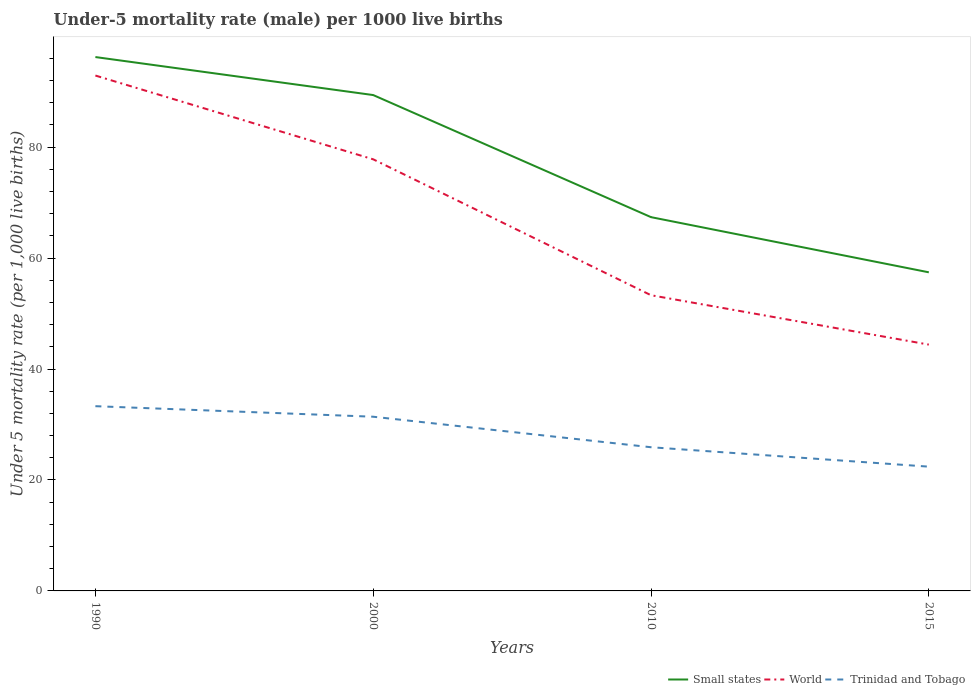Is the number of lines equal to the number of legend labels?
Keep it short and to the point. Yes. Across all years, what is the maximum under-five mortality rate in Small states?
Make the answer very short. 57.43. In which year was the under-five mortality rate in World maximum?
Your answer should be compact. 2015. What is the difference between the highest and the second highest under-five mortality rate in World?
Make the answer very short. 48.5. Is the under-five mortality rate in Small states strictly greater than the under-five mortality rate in Trinidad and Tobago over the years?
Your response must be concise. No. Does the graph contain any zero values?
Your response must be concise. No. How many legend labels are there?
Provide a succinct answer. 3. What is the title of the graph?
Provide a short and direct response. Under-5 mortality rate (male) per 1000 live births. What is the label or title of the Y-axis?
Provide a succinct answer. Under 5 mortality rate (per 1,0 live births). What is the Under 5 mortality rate (per 1,000 live births) in Small states in 1990?
Give a very brief answer. 96.23. What is the Under 5 mortality rate (per 1,000 live births) of World in 1990?
Give a very brief answer. 92.9. What is the Under 5 mortality rate (per 1,000 live births) in Trinidad and Tobago in 1990?
Your answer should be very brief. 33.3. What is the Under 5 mortality rate (per 1,000 live births) in Small states in 2000?
Keep it short and to the point. 89.38. What is the Under 5 mortality rate (per 1,000 live births) in World in 2000?
Provide a short and direct response. 77.8. What is the Under 5 mortality rate (per 1,000 live births) of Trinidad and Tobago in 2000?
Your answer should be compact. 31.4. What is the Under 5 mortality rate (per 1,000 live births) in Small states in 2010?
Your answer should be compact. 67.37. What is the Under 5 mortality rate (per 1,000 live births) in World in 2010?
Make the answer very short. 53.3. What is the Under 5 mortality rate (per 1,000 live births) in Trinidad and Tobago in 2010?
Offer a very short reply. 25.9. What is the Under 5 mortality rate (per 1,000 live births) of Small states in 2015?
Ensure brevity in your answer.  57.43. What is the Under 5 mortality rate (per 1,000 live births) in World in 2015?
Offer a very short reply. 44.4. What is the Under 5 mortality rate (per 1,000 live births) in Trinidad and Tobago in 2015?
Make the answer very short. 22.4. Across all years, what is the maximum Under 5 mortality rate (per 1,000 live births) of Small states?
Provide a short and direct response. 96.23. Across all years, what is the maximum Under 5 mortality rate (per 1,000 live births) in World?
Provide a short and direct response. 92.9. Across all years, what is the maximum Under 5 mortality rate (per 1,000 live births) of Trinidad and Tobago?
Provide a short and direct response. 33.3. Across all years, what is the minimum Under 5 mortality rate (per 1,000 live births) of Small states?
Your answer should be very brief. 57.43. Across all years, what is the minimum Under 5 mortality rate (per 1,000 live births) in World?
Make the answer very short. 44.4. Across all years, what is the minimum Under 5 mortality rate (per 1,000 live births) in Trinidad and Tobago?
Your response must be concise. 22.4. What is the total Under 5 mortality rate (per 1,000 live births) of Small states in the graph?
Keep it short and to the point. 310.42. What is the total Under 5 mortality rate (per 1,000 live births) in World in the graph?
Ensure brevity in your answer.  268.4. What is the total Under 5 mortality rate (per 1,000 live births) in Trinidad and Tobago in the graph?
Keep it short and to the point. 113. What is the difference between the Under 5 mortality rate (per 1,000 live births) in Small states in 1990 and that in 2000?
Your response must be concise. 6.85. What is the difference between the Under 5 mortality rate (per 1,000 live births) of World in 1990 and that in 2000?
Offer a terse response. 15.1. What is the difference between the Under 5 mortality rate (per 1,000 live births) in Trinidad and Tobago in 1990 and that in 2000?
Ensure brevity in your answer.  1.9. What is the difference between the Under 5 mortality rate (per 1,000 live births) of Small states in 1990 and that in 2010?
Keep it short and to the point. 28.86. What is the difference between the Under 5 mortality rate (per 1,000 live births) in World in 1990 and that in 2010?
Give a very brief answer. 39.6. What is the difference between the Under 5 mortality rate (per 1,000 live births) of Trinidad and Tobago in 1990 and that in 2010?
Give a very brief answer. 7.4. What is the difference between the Under 5 mortality rate (per 1,000 live births) in Small states in 1990 and that in 2015?
Give a very brief answer. 38.8. What is the difference between the Under 5 mortality rate (per 1,000 live births) in World in 1990 and that in 2015?
Give a very brief answer. 48.5. What is the difference between the Under 5 mortality rate (per 1,000 live births) in Trinidad and Tobago in 1990 and that in 2015?
Your answer should be compact. 10.9. What is the difference between the Under 5 mortality rate (per 1,000 live births) of Small states in 2000 and that in 2010?
Keep it short and to the point. 22.01. What is the difference between the Under 5 mortality rate (per 1,000 live births) in World in 2000 and that in 2010?
Provide a succinct answer. 24.5. What is the difference between the Under 5 mortality rate (per 1,000 live births) in Small states in 2000 and that in 2015?
Ensure brevity in your answer.  31.95. What is the difference between the Under 5 mortality rate (per 1,000 live births) of World in 2000 and that in 2015?
Your answer should be compact. 33.4. What is the difference between the Under 5 mortality rate (per 1,000 live births) in Trinidad and Tobago in 2000 and that in 2015?
Keep it short and to the point. 9. What is the difference between the Under 5 mortality rate (per 1,000 live births) of Small states in 2010 and that in 2015?
Offer a terse response. 9.94. What is the difference between the Under 5 mortality rate (per 1,000 live births) of Small states in 1990 and the Under 5 mortality rate (per 1,000 live births) of World in 2000?
Offer a terse response. 18.43. What is the difference between the Under 5 mortality rate (per 1,000 live births) of Small states in 1990 and the Under 5 mortality rate (per 1,000 live births) of Trinidad and Tobago in 2000?
Offer a very short reply. 64.83. What is the difference between the Under 5 mortality rate (per 1,000 live births) in World in 1990 and the Under 5 mortality rate (per 1,000 live births) in Trinidad and Tobago in 2000?
Make the answer very short. 61.5. What is the difference between the Under 5 mortality rate (per 1,000 live births) of Small states in 1990 and the Under 5 mortality rate (per 1,000 live births) of World in 2010?
Keep it short and to the point. 42.93. What is the difference between the Under 5 mortality rate (per 1,000 live births) of Small states in 1990 and the Under 5 mortality rate (per 1,000 live births) of Trinidad and Tobago in 2010?
Provide a short and direct response. 70.33. What is the difference between the Under 5 mortality rate (per 1,000 live births) of Small states in 1990 and the Under 5 mortality rate (per 1,000 live births) of World in 2015?
Offer a very short reply. 51.83. What is the difference between the Under 5 mortality rate (per 1,000 live births) of Small states in 1990 and the Under 5 mortality rate (per 1,000 live births) of Trinidad and Tobago in 2015?
Keep it short and to the point. 73.83. What is the difference between the Under 5 mortality rate (per 1,000 live births) in World in 1990 and the Under 5 mortality rate (per 1,000 live births) in Trinidad and Tobago in 2015?
Your response must be concise. 70.5. What is the difference between the Under 5 mortality rate (per 1,000 live births) of Small states in 2000 and the Under 5 mortality rate (per 1,000 live births) of World in 2010?
Offer a very short reply. 36.08. What is the difference between the Under 5 mortality rate (per 1,000 live births) in Small states in 2000 and the Under 5 mortality rate (per 1,000 live births) in Trinidad and Tobago in 2010?
Provide a succinct answer. 63.48. What is the difference between the Under 5 mortality rate (per 1,000 live births) in World in 2000 and the Under 5 mortality rate (per 1,000 live births) in Trinidad and Tobago in 2010?
Provide a short and direct response. 51.9. What is the difference between the Under 5 mortality rate (per 1,000 live births) in Small states in 2000 and the Under 5 mortality rate (per 1,000 live births) in World in 2015?
Offer a very short reply. 44.98. What is the difference between the Under 5 mortality rate (per 1,000 live births) in Small states in 2000 and the Under 5 mortality rate (per 1,000 live births) in Trinidad and Tobago in 2015?
Keep it short and to the point. 66.98. What is the difference between the Under 5 mortality rate (per 1,000 live births) in World in 2000 and the Under 5 mortality rate (per 1,000 live births) in Trinidad and Tobago in 2015?
Provide a succinct answer. 55.4. What is the difference between the Under 5 mortality rate (per 1,000 live births) in Small states in 2010 and the Under 5 mortality rate (per 1,000 live births) in World in 2015?
Give a very brief answer. 22.97. What is the difference between the Under 5 mortality rate (per 1,000 live births) in Small states in 2010 and the Under 5 mortality rate (per 1,000 live births) in Trinidad and Tobago in 2015?
Ensure brevity in your answer.  44.97. What is the difference between the Under 5 mortality rate (per 1,000 live births) of World in 2010 and the Under 5 mortality rate (per 1,000 live births) of Trinidad and Tobago in 2015?
Offer a very short reply. 30.9. What is the average Under 5 mortality rate (per 1,000 live births) of Small states per year?
Your answer should be very brief. 77.6. What is the average Under 5 mortality rate (per 1,000 live births) of World per year?
Give a very brief answer. 67.1. What is the average Under 5 mortality rate (per 1,000 live births) in Trinidad and Tobago per year?
Keep it short and to the point. 28.25. In the year 1990, what is the difference between the Under 5 mortality rate (per 1,000 live births) of Small states and Under 5 mortality rate (per 1,000 live births) of World?
Provide a succinct answer. 3.33. In the year 1990, what is the difference between the Under 5 mortality rate (per 1,000 live births) of Small states and Under 5 mortality rate (per 1,000 live births) of Trinidad and Tobago?
Make the answer very short. 62.93. In the year 1990, what is the difference between the Under 5 mortality rate (per 1,000 live births) in World and Under 5 mortality rate (per 1,000 live births) in Trinidad and Tobago?
Provide a short and direct response. 59.6. In the year 2000, what is the difference between the Under 5 mortality rate (per 1,000 live births) in Small states and Under 5 mortality rate (per 1,000 live births) in World?
Give a very brief answer. 11.58. In the year 2000, what is the difference between the Under 5 mortality rate (per 1,000 live births) in Small states and Under 5 mortality rate (per 1,000 live births) in Trinidad and Tobago?
Offer a terse response. 57.98. In the year 2000, what is the difference between the Under 5 mortality rate (per 1,000 live births) of World and Under 5 mortality rate (per 1,000 live births) of Trinidad and Tobago?
Your response must be concise. 46.4. In the year 2010, what is the difference between the Under 5 mortality rate (per 1,000 live births) of Small states and Under 5 mortality rate (per 1,000 live births) of World?
Give a very brief answer. 14.07. In the year 2010, what is the difference between the Under 5 mortality rate (per 1,000 live births) in Small states and Under 5 mortality rate (per 1,000 live births) in Trinidad and Tobago?
Keep it short and to the point. 41.47. In the year 2010, what is the difference between the Under 5 mortality rate (per 1,000 live births) of World and Under 5 mortality rate (per 1,000 live births) of Trinidad and Tobago?
Your answer should be compact. 27.4. In the year 2015, what is the difference between the Under 5 mortality rate (per 1,000 live births) of Small states and Under 5 mortality rate (per 1,000 live births) of World?
Keep it short and to the point. 13.03. In the year 2015, what is the difference between the Under 5 mortality rate (per 1,000 live births) in Small states and Under 5 mortality rate (per 1,000 live births) in Trinidad and Tobago?
Your response must be concise. 35.03. In the year 2015, what is the difference between the Under 5 mortality rate (per 1,000 live births) of World and Under 5 mortality rate (per 1,000 live births) of Trinidad and Tobago?
Provide a short and direct response. 22. What is the ratio of the Under 5 mortality rate (per 1,000 live births) in Small states in 1990 to that in 2000?
Your answer should be very brief. 1.08. What is the ratio of the Under 5 mortality rate (per 1,000 live births) of World in 1990 to that in 2000?
Your answer should be compact. 1.19. What is the ratio of the Under 5 mortality rate (per 1,000 live births) in Trinidad and Tobago in 1990 to that in 2000?
Your answer should be compact. 1.06. What is the ratio of the Under 5 mortality rate (per 1,000 live births) in Small states in 1990 to that in 2010?
Your answer should be very brief. 1.43. What is the ratio of the Under 5 mortality rate (per 1,000 live births) of World in 1990 to that in 2010?
Provide a succinct answer. 1.74. What is the ratio of the Under 5 mortality rate (per 1,000 live births) of Trinidad and Tobago in 1990 to that in 2010?
Ensure brevity in your answer.  1.29. What is the ratio of the Under 5 mortality rate (per 1,000 live births) in Small states in 1990 to that in 2015?
Offer a terse response. 1.68. What is the ratio of the Under 5 mortality rate (per 1,000 live births) of World in 1990 to that in 2015?
Your answer should be compact. 2.09. What is the ratio of the Under 5 mortality rate (per 1,000 live births) of Trinidad and Tobago in 1990 to that in 2015?
Your response must be concise. 1.49. What is the ratio of the Under 5 mortality rate (per 1,000 live births) in Small states in 2000 to that in 2010?
Provide a succinct answer. 1.33. What is the ratio of the Under 5 mortality rate (per 1,000 live births) of World in 2000 to that in 2010?
Your answer should be very brief. 1.46. What is the ratio of the Under 5 mortality rate (per 1,000 live births) of Trinidad and Tobago in 2000 to that in 2010?
Offer a very short reply. 1.21. What is the ratio of the Under 5 mortality rate (per 1,000 live births) in Small states in 2000 to that in 2015?
Your response must be concise. 1.56. What is the ratio of the Under 5 mortality rate (per 1,000 live births) in World in 2000 to that in 2015?
Offer a terse response. 1.75. What is the ratio of the Under 5 mortality rate (per 1,000 live births) of Trinidad and Tobago in 2000 to that in 2015?
Give a very brief answer. 1.4. What is the ratio of the Under 5 mortality rate (per 1,000 live births) in Small states in 2010 to that in 2015?
Provide a short and direct response. 1.17. What is the ratio of the Under 5 mortality rate (per 1,000 live births) of World in 2010 to that in 2015?
Your answer should be very brief. 1.2. What is the ratio of the Under 5 mortality rate (per 1,000 live births) in Trinidad and Tobago in 2010 to that in 2015?
Your answer should be compact. 1.16. What is the difference between the highest and the second highest Under 5 mortality rate (per 1,000 live births) of Small states?
Keep it short and to the point. 6.85. What is the difference between the highest and the second highest Under 5 mortality rate (per 1,000 live births) in Trinidad and Tobago?
Offer a terse response. 1.9. What is the difference between the highest and the lowest Under 5 mortality rate (per 1,000 live births) of Small states?
Provide a short and direct response. 38.8. What is the difference between the highest and the lowest Under 5 mortality rate (per 1,000 live births) of World?
Make the answer very short. 48.5. What is the difference between the highest and the lowest Under 5 mortality rate (per 1,000 live births) of Trinidad and Tobago?
Provide a short and direct response. 10.9. 